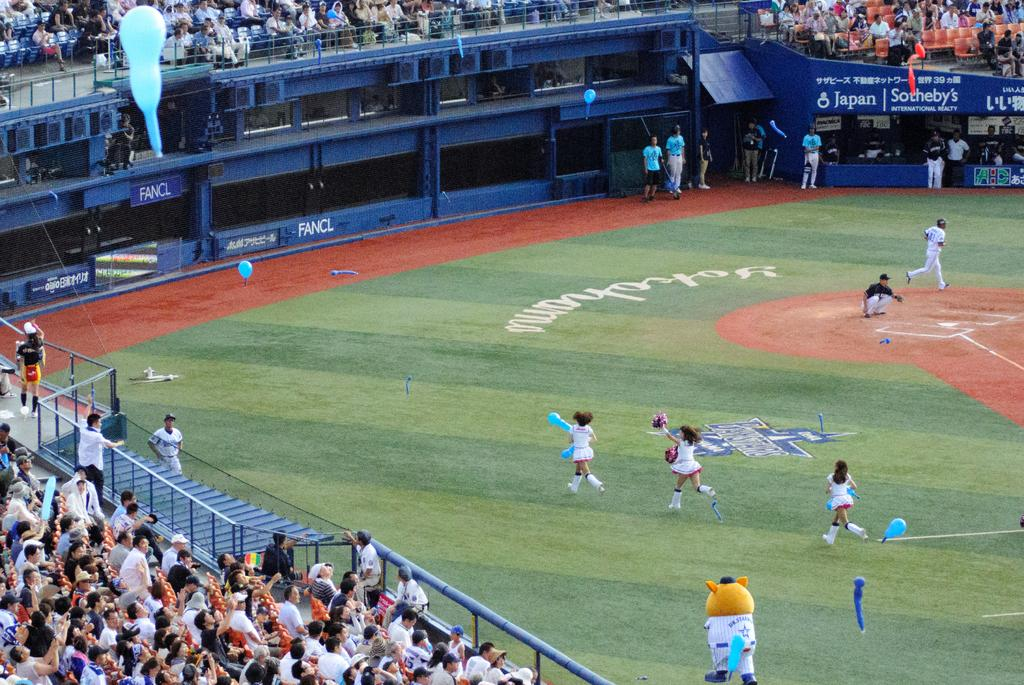<image>
Present a compact description of the photo's key features. Children and a mascot are running across a baseball field that has a sign that says, 'Fancl', on it. 